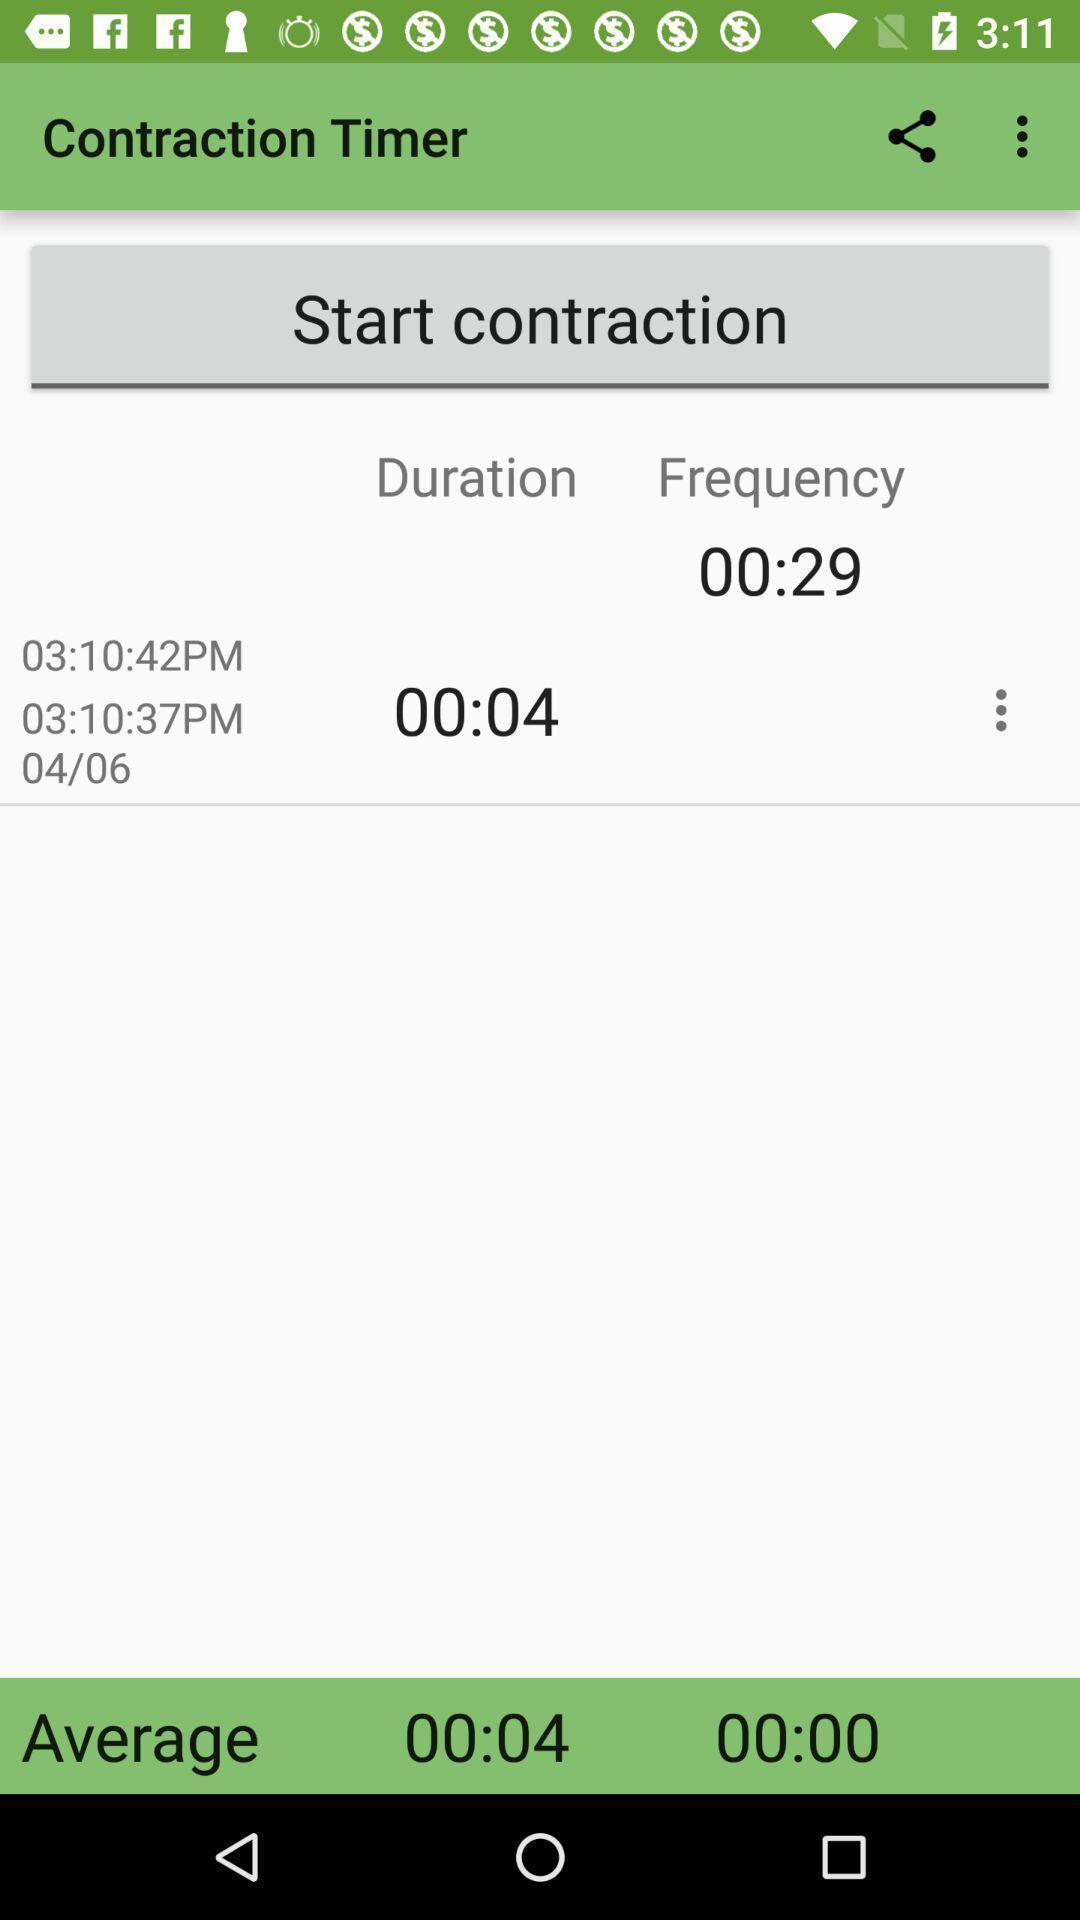Describe the visual elements of this screenshot. Timer page. 